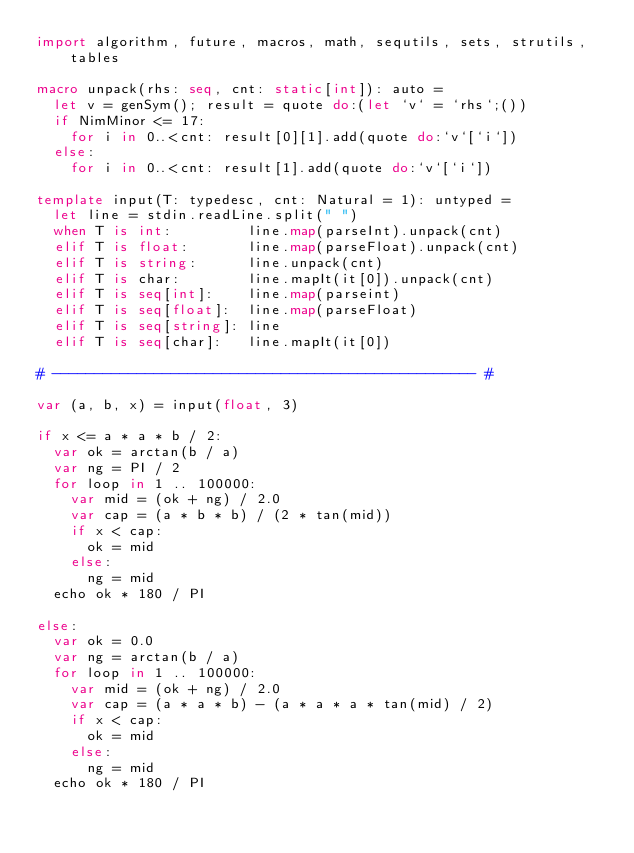Convert code to text. <code><loc_0><loc_0><loc_500><loc_500><_Nim_>import algorithm, future, macros, math, sequtils, sets, strutils, tables

macro unpack(rhs: seq, cnt: static[int]): auto =
  let v = genSym(); result = quote do:(let `v` = `rhs`;())
  if NimMinor <= 17:
    for i in 0..<cnt: result[0][1].add(quote do:`v`[`i`])
  else:
    for i in 0..<cnt: result[1].add(quote do:`v`[`i`])

template input(T: typedesc, cnt: Natural = 1): untyped =
  let line = stdin.readLine.split(" ")
  when T is int:         line.map(parseInt).unpack(cnt)
  elif T is float:       line.map(parseFloat).unpack(cnt)
  elif T is string:      line.unpack(cnt)
  elif T is char:        line.mapIt(it[0]).unpack(cnt)
  elif T is seq[int]:    line.map(parseint)
  elif T is seq[float]:  line.map(parseFloat)
  elif T is seq[string]: line
  elif T is seq[char]:   line.mapIt(it[0])

# -------------------------------------------------- #

var (a, b, x) = input(float, 3)
 
if x <= a * a * b / 2:
  var ok = arctan(b / a)
  var ng = PI / 2
  for loop in 1 .. 100000:
    var mid = (ok + ng) / 2.0
    var cap = (a * b * b) / (2 * tan(mid))
    if x < cap:
      ok = mid
    else:
      ng = mid
  echo ok * 180 / PI

else:
  var ok = 0.0
  var ng = arctan(b / a)
  for loop in 1 .. 100000:
    var mid = (ok + ng) / 2.0
    var cap = (a * a * b) - (a * a * a * tan(mid) / 2)
    if x < cap:
      ok = mid
    else:
      ng = mid
  echo ok * 180 / PI</code> 